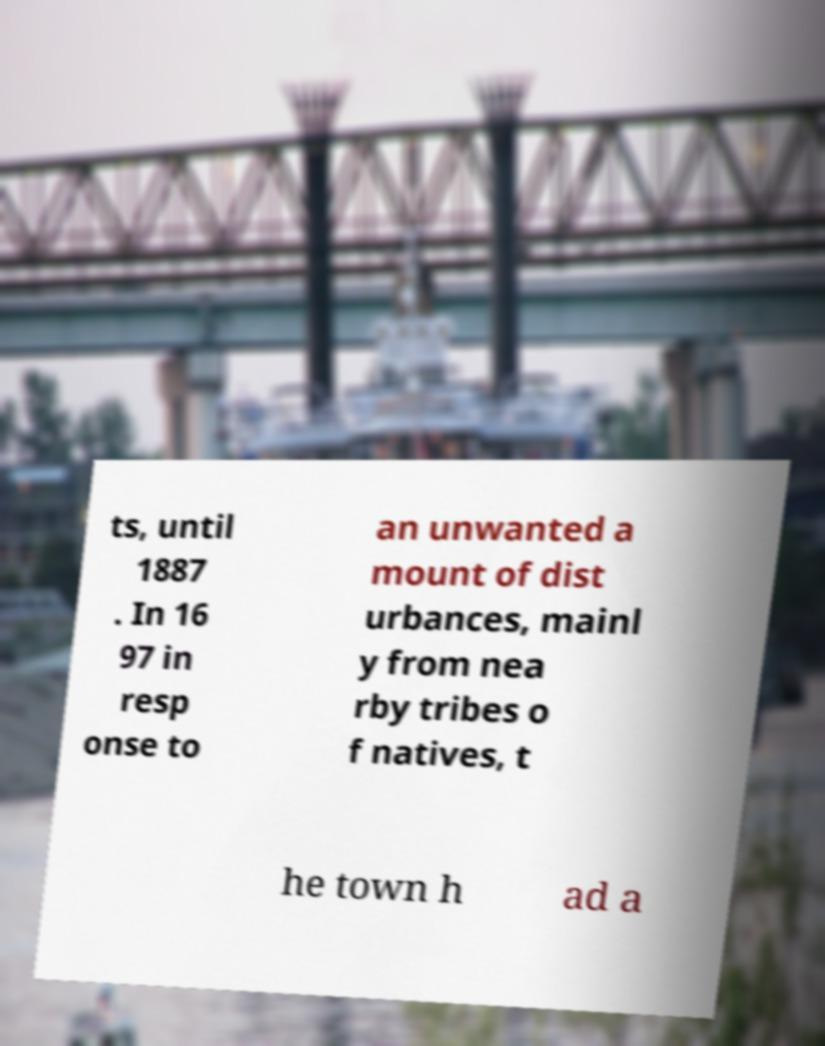For documentation purposes, I need the text within this image transcribed. Could you provide that? ts, until 1887 . In 16 97 in resp onse to an unwanted a mount of dist urbances, mainl y from nea rby tribes o f natives, t he town h ad a 